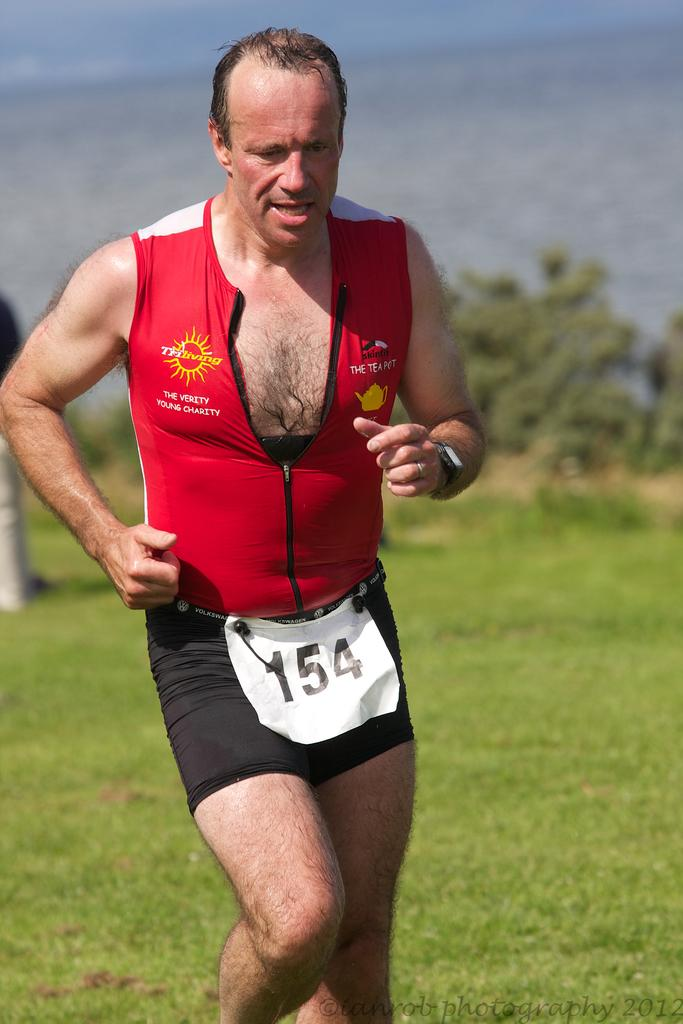Who is present in the image? There is a person in the image. What is the person wearing? The person is wearing a red and black color dress. What is the person doing in the image? The person is running. What can be seen in the background of the image? There are trees in the background of the image. How many slices of pie can be seen in the image? There is no pie present in the image. 